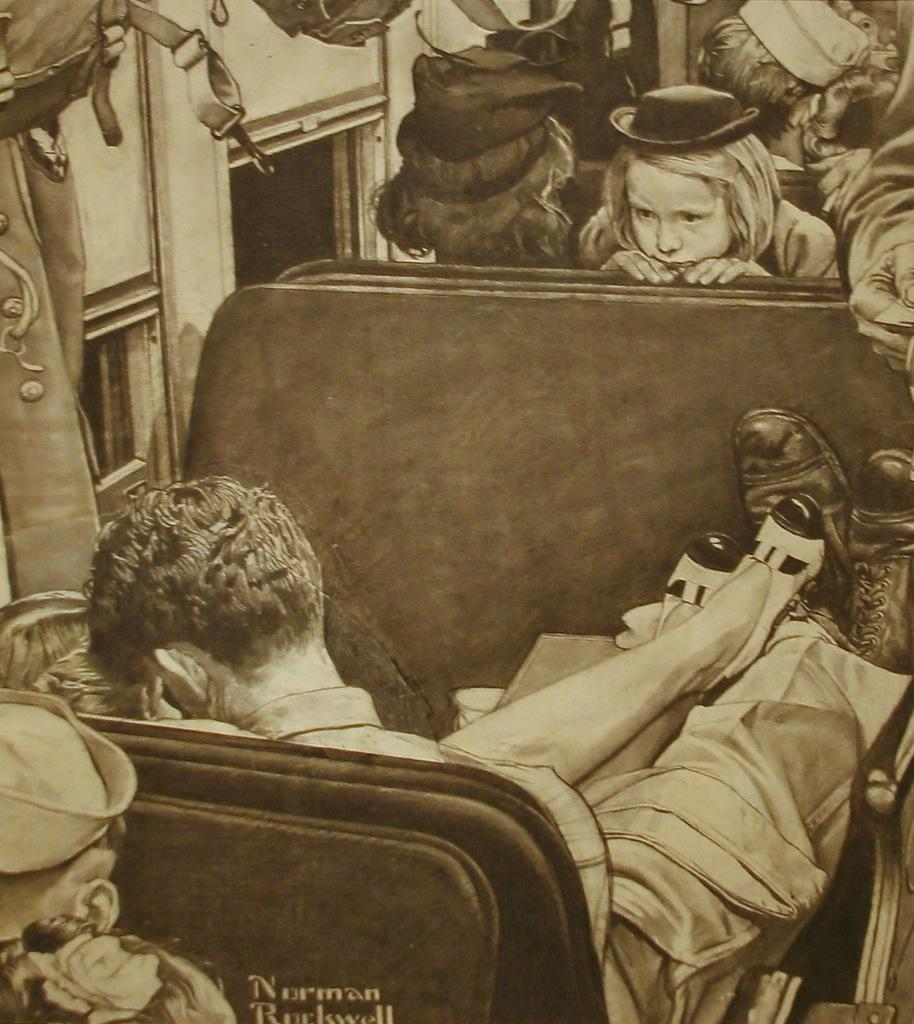What type of artwork is depicted in the image? The image is a painting. What is happening in the painting? There is a group of people sitting in the painting. Can you describe any specific details about the seating in the painting? There is text on the seat in the painting. What is present on the left side of the painting? There is a curtain on the left side of the painting. Are there any architectural features visible in the painting? Yes, there are windows in the painting. What type of eggnog is being served to the band in the painting? There is no band or eggnog present in the painting; it features a group of people sitting and does not depict any musical performances or beverages. 